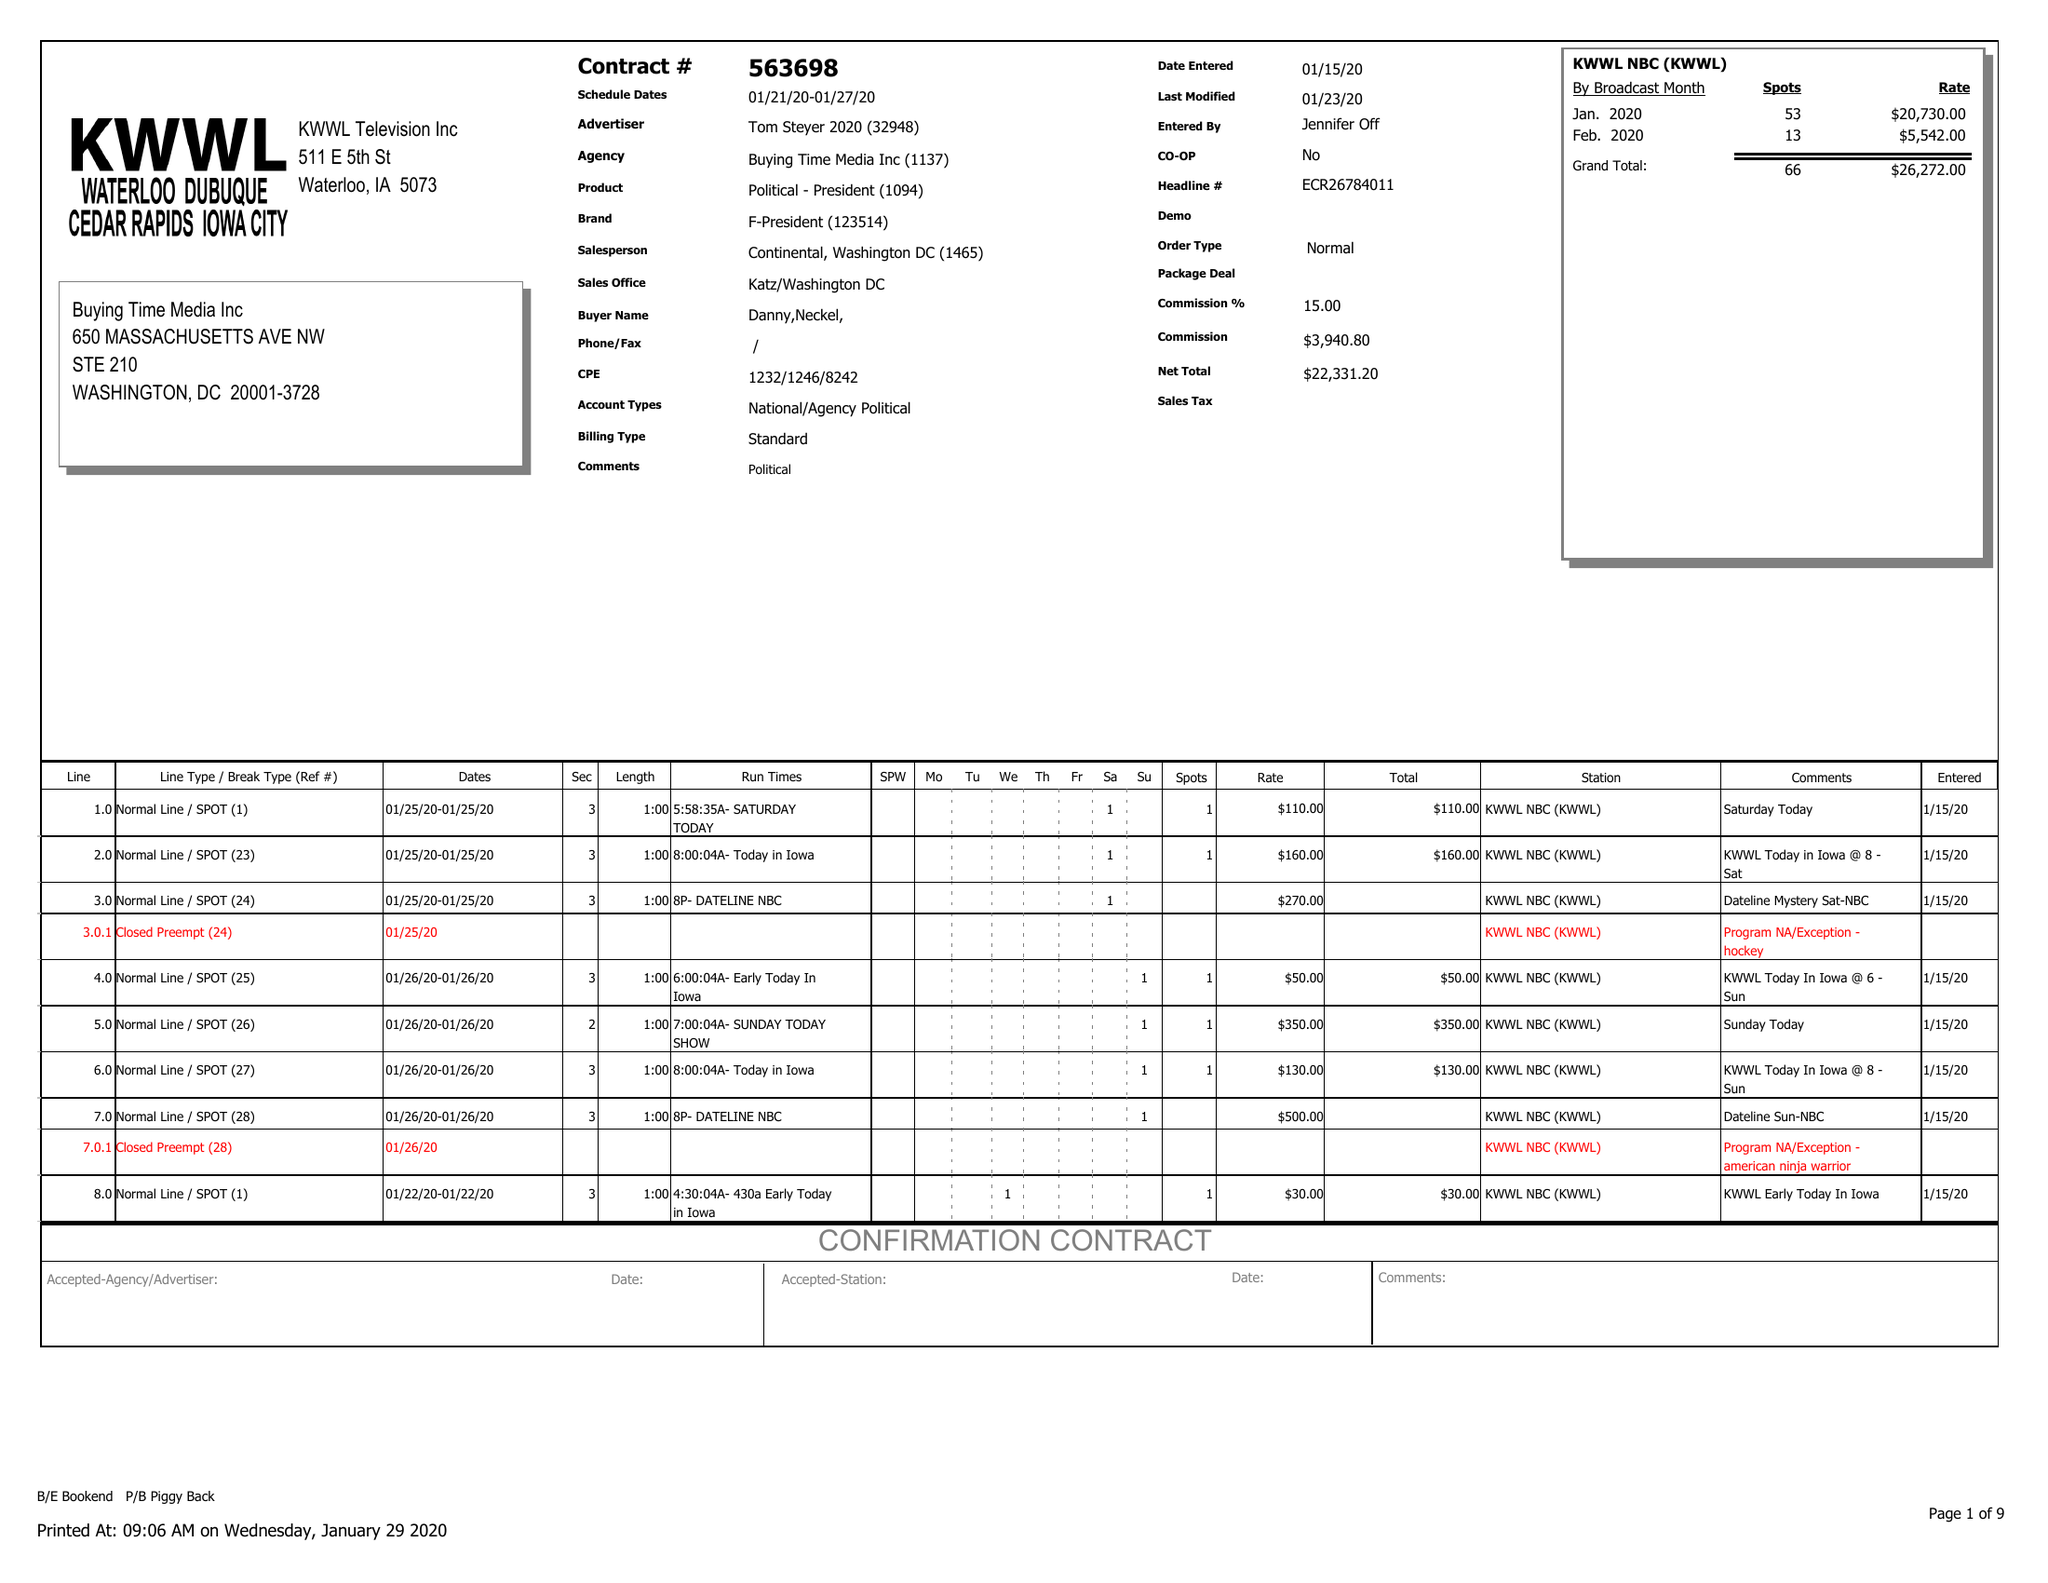What is the value for the flight_from?
Answer the question using a single word or phrase. 01/21/20 